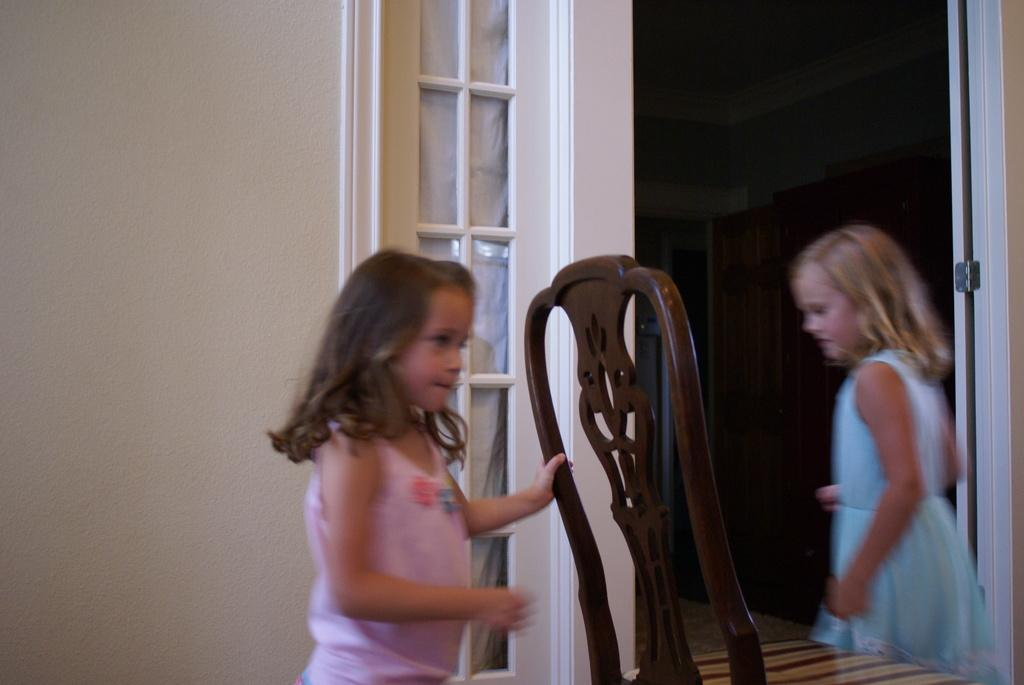What is the girl on the left side of the image wearing? The girl on the left side of the image is wearing a pink color dress. What is the girl on the left side of the image holding? The girl in the pink dress is holding a wooden chair. What is the girl on the right side of the image wearing? The girl on the right side of the image is wearing a blue color dress. What can be seen in the background of the image? There is a white wall in the background of the image. What type of bird can be seen flying in the image? There is no bird present in the image. What color is the meeting in the image? There is no meeting present in the image, so it cannot be assigned a color. 